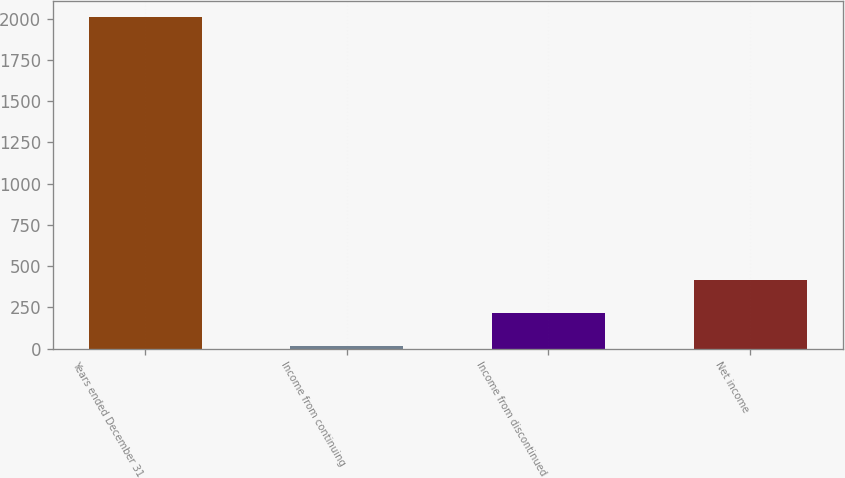Convert chart. <chart><loc_0><loc_0><loc_500><loc_500><bar_chart><fcel>Years ended December 31<fcel>Income from continuing<fcel>Income from discontinued<fcel>Net income<nl><fcel>2008<fcel>15<fcel>214.3<fcel>413.6<nl></chart> 